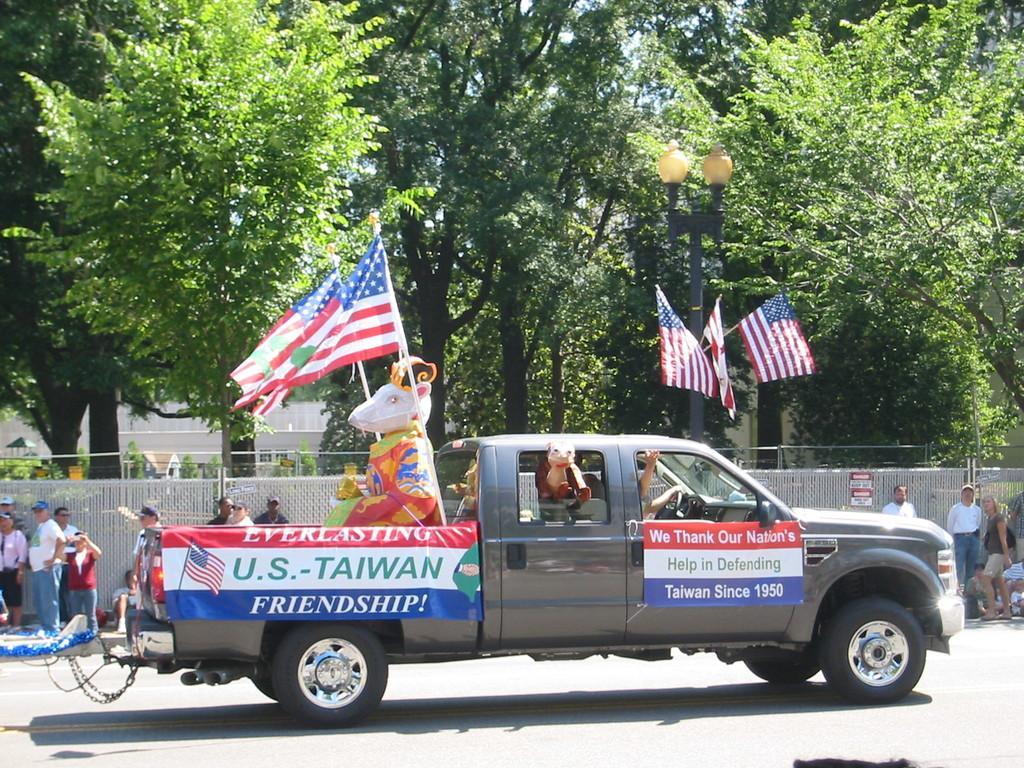How would you summarize this image in a sentence or two? In this image I see a truck on which there is a statue and I see flags and I see 2 banners on which I there are words and numbers and I see the road. In the background I see people, fencing, light pole and I see the trees. 